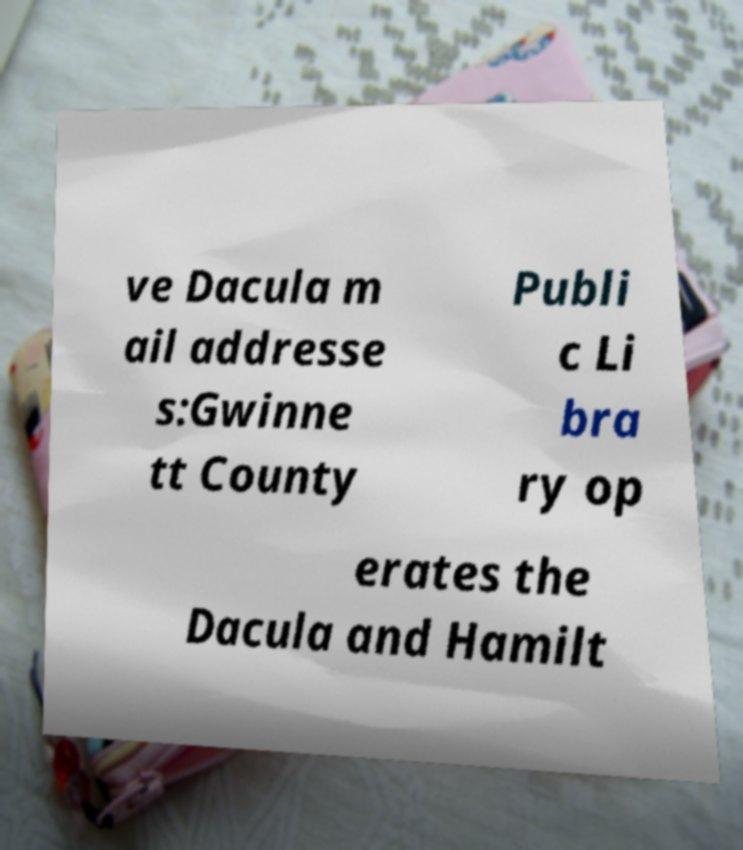Can you read and provide the text displayed in the image?This photo seems to have some interesting text. Can you extract and type it out for me? ve Dacula m ail addresse s:Gwinne tt County Publi c Li bra ry op erates the Dacula and Hamilt 